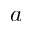<formula> <loc_0><loc_0><loc_500><loc_500>a</formula> 